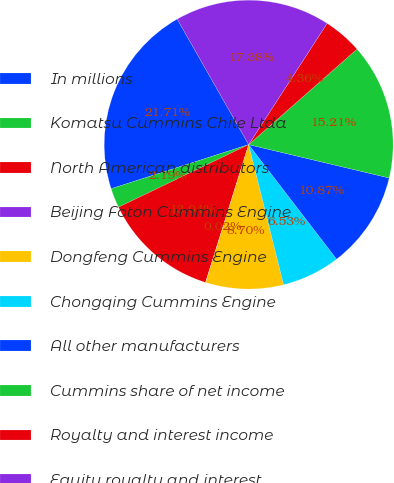<chart> <loc_0><loc_0><loc_500><loc_500><pie_chart><fcel>In millions<fcel>Komatsu Cummins Chile Ltda<fcel>North American distributors<fcel>Beijing Foton Cummins Engine<fcel>Dongfeng Cummins Engine<fcel>Chongqing Cummins Engine<fcel>All other manufacturers<fcel>Cummins share of net income<fcel>Royalty and interest income<fcel>Equity royalty and interest<nl><fcel>21.71%<fcel>2.19%<fcel>13.04%<fcel>0.02%<fcel>8.7%<fcel>6.53%<fcel>10.87%<fcel>15.21%<fcel>4.36%<fcel>17.38%<nl></chart> 